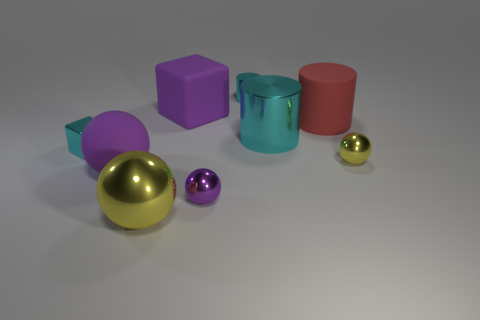How many tiny things are purple balls or metallic cylinders?
Offer a very short reply. 2. Are there any tiny purple objects?
Your response must be concise. Yes. Are there more small metallic things on the left side of the red cylinder than cubes that are in front of the small purple shiny ball?
Your response must be concise. Yes. The cube that is on the right side of the thing in front of the small purple metal ball is what color?
Ensure brevity in your answer.  Purple. Are there any big metal cylinders of the same color as the rubber block?
Keep it short and to the point. No. What size is the cylinder that is in front of the big rubber cylinder on the right side of the tiny cyan object right of the small purple shiny thing?
Make the answer very short. Large. The red object is what shape?
Keep it short and to the point. Cylinder. There is another metal cylinder that is the same color as the small cylinder; what is its size?
Your response must be concise. Large. How many blocks are to the right of the large purple object in front of the large rubber block?
Provide a short and direct response. 1. How many other things are the same material as the big cyan thing?
Provide a succinct answer. 5. 